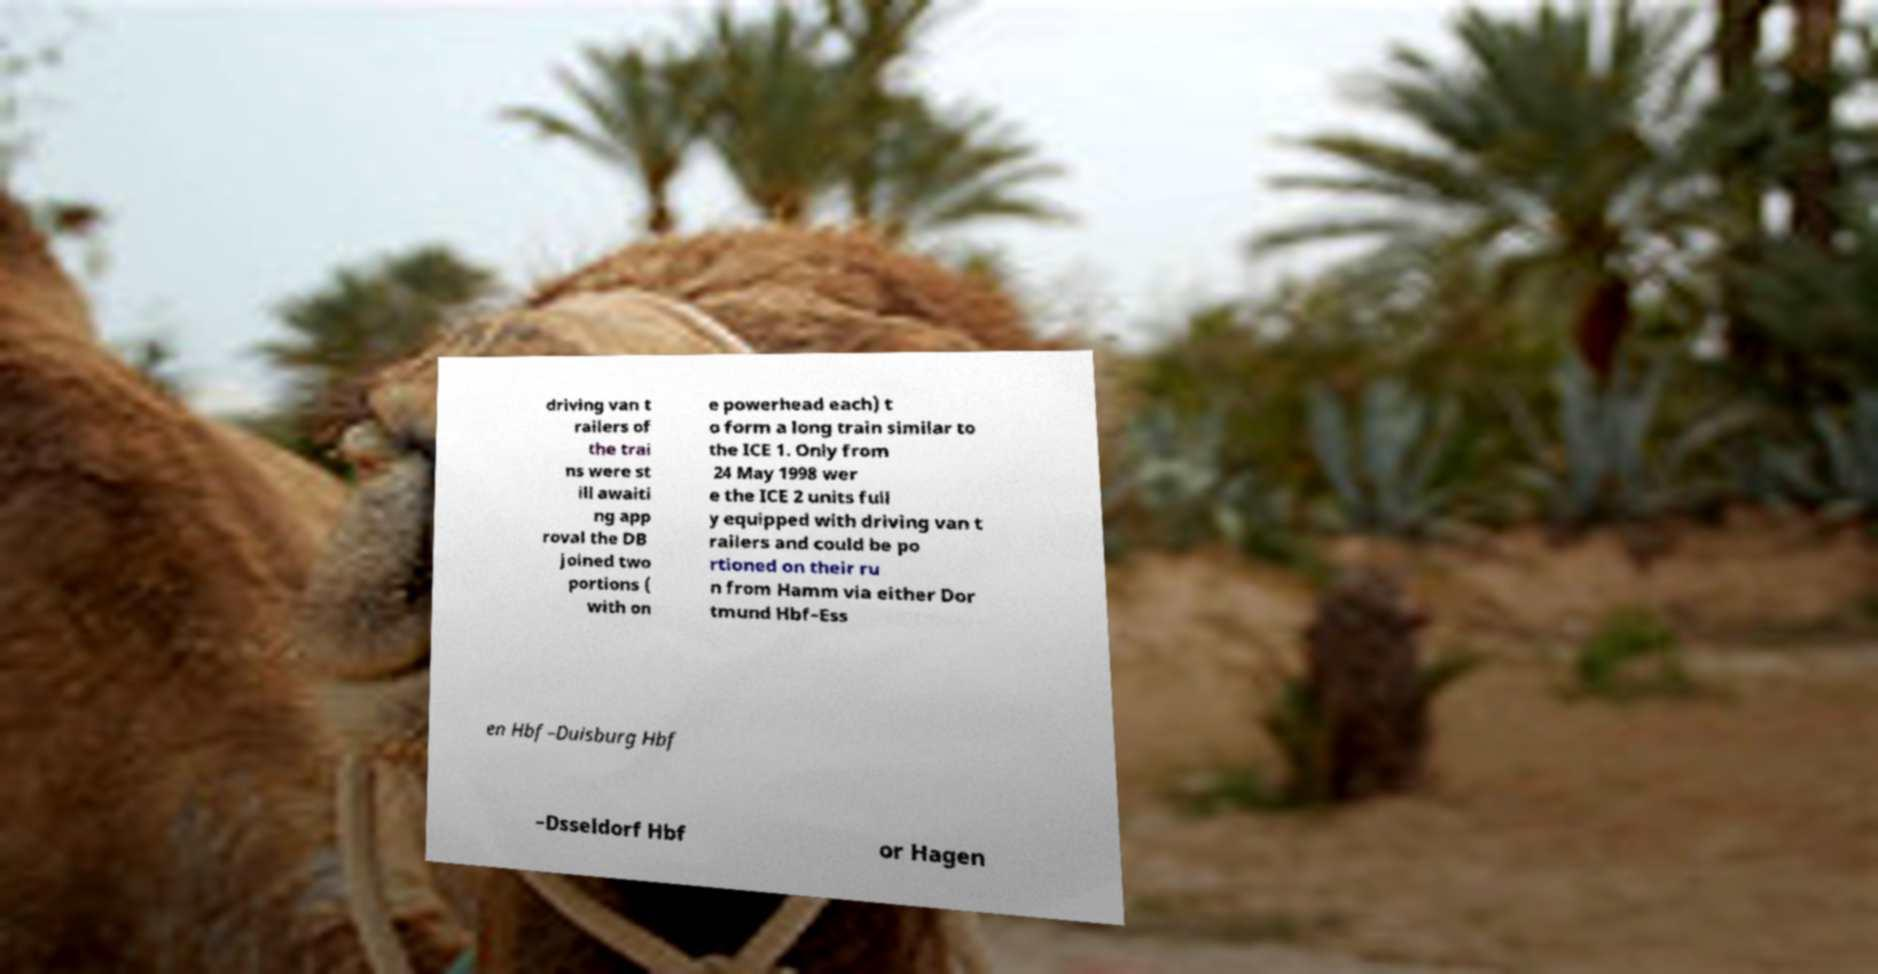Please read and relay the text visible in this image. What does it say? driving van t railers of the trai ns were st ill awaiti ng app roval the DB joined two portions ( with on e powerhead each) t o form a long train similar to the ICE 1. Only from 24 May 1998 wer e the ICE 2 units full y equipped with driving van t railers and could be po rtioned on their ru n from Hamm via either Dor tmund Hbf–Ess en Hbf–Duisburg Hbf –Dsseldorf Hbf or Hagen 